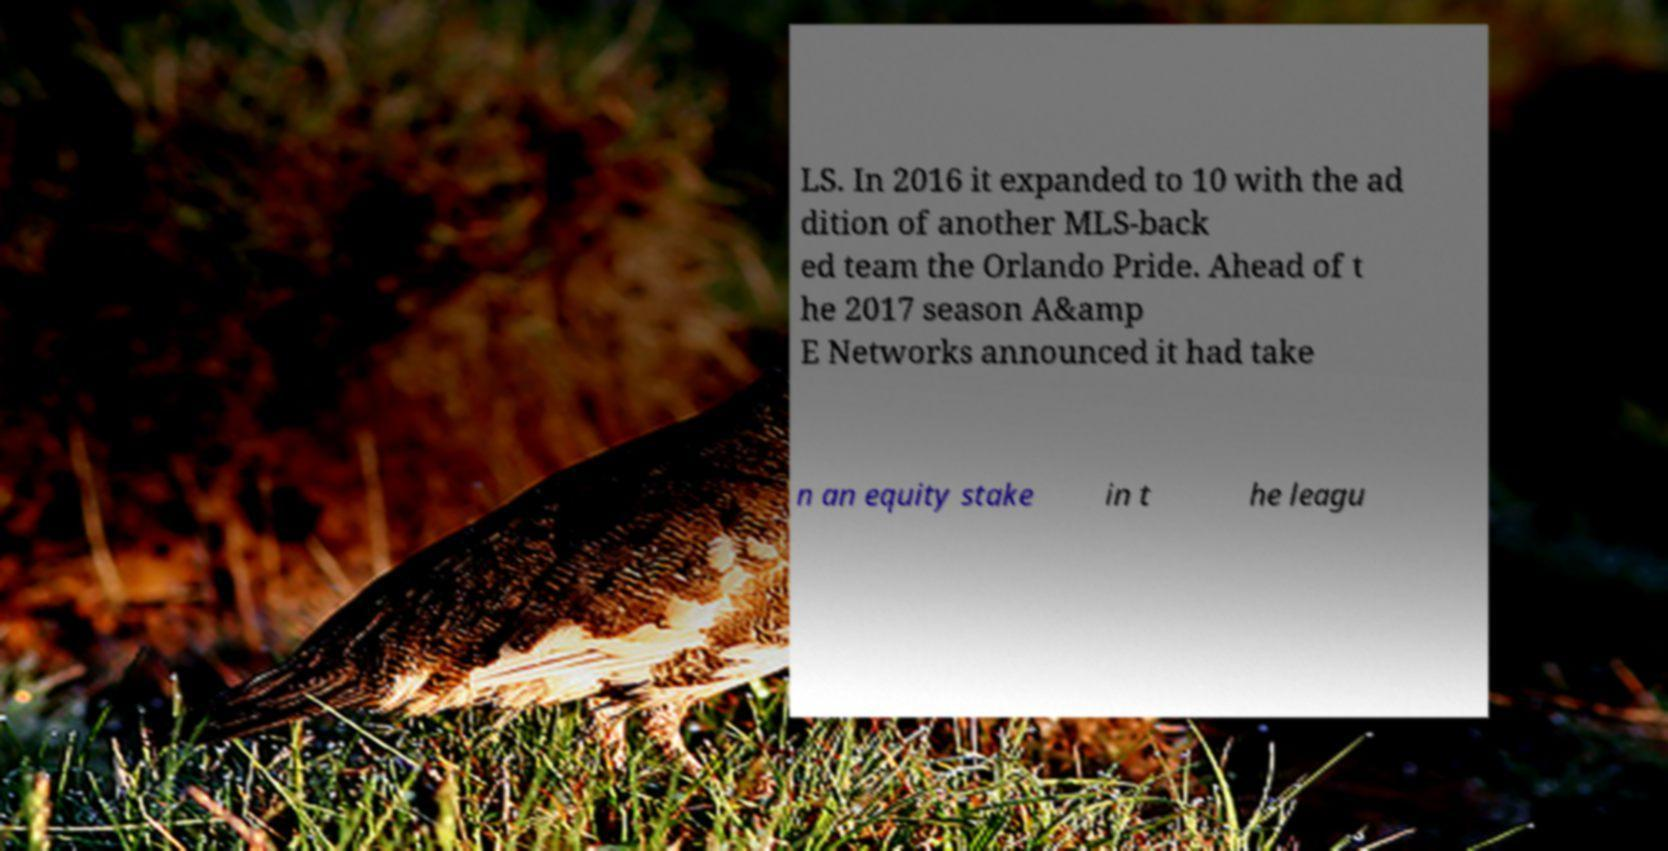Can you accurately transcribe the text from the provided image for me? LS. In 2016 it expanded to 10 with the ad dition of another MLS-back ed team the Orlando Pride. Ahead of t he 2017 season A&amp E Networks announced it had take n an equity stake in t he leagu 